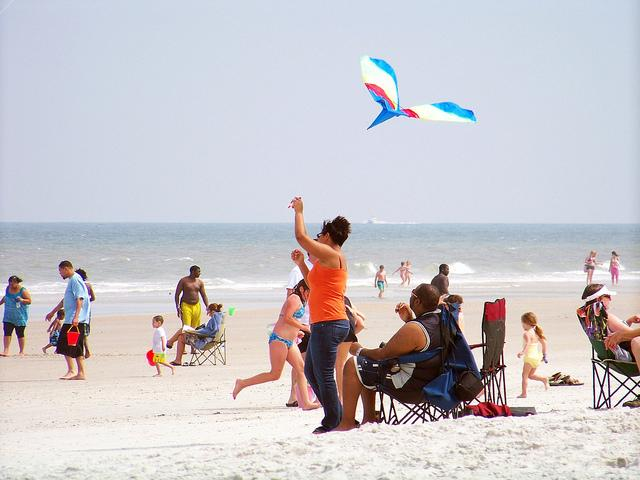What is missing in the picture that is typical at beaches? Please explain your reasoning. umbrellas. They give shade from the sun. 